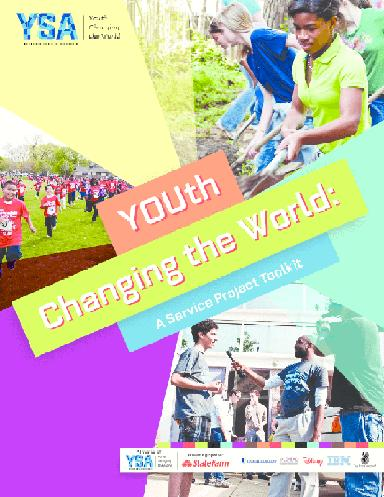What organization is associated with this message? The acronym 'YSA' stands for Youth Service America, an organization that spearheads this empowering call to action, supporting and facilitating young people's involvement in community service and civic engagement. Their efforts are showcased in the brochure, which stands as both an invitation and a guide for young activists to initiate change. 